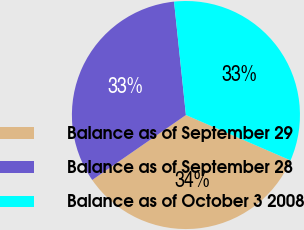Convert chart to OTSL. <chart><loc_0><loc_0><loc_500><loc_500><pie_chart><fcel>Balance as of September 29<fcel>Balance as of September 28<fcel>Balance as of October 3 2008<nl><fcel>33.84%<fcel>32.98%<fcel>33.17%<nl></chart> 